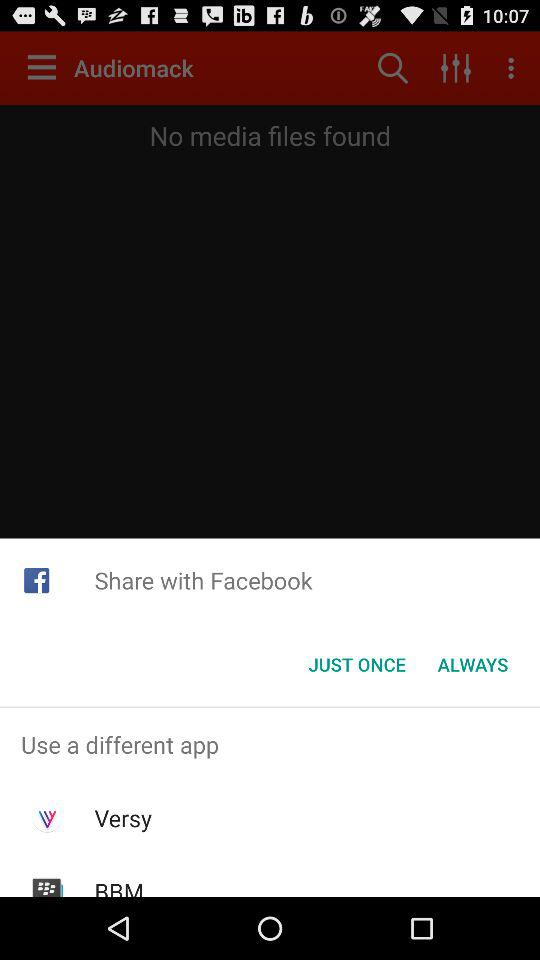Through what applications can content be shared? It can be shared through "Facebook" and "Versy". 